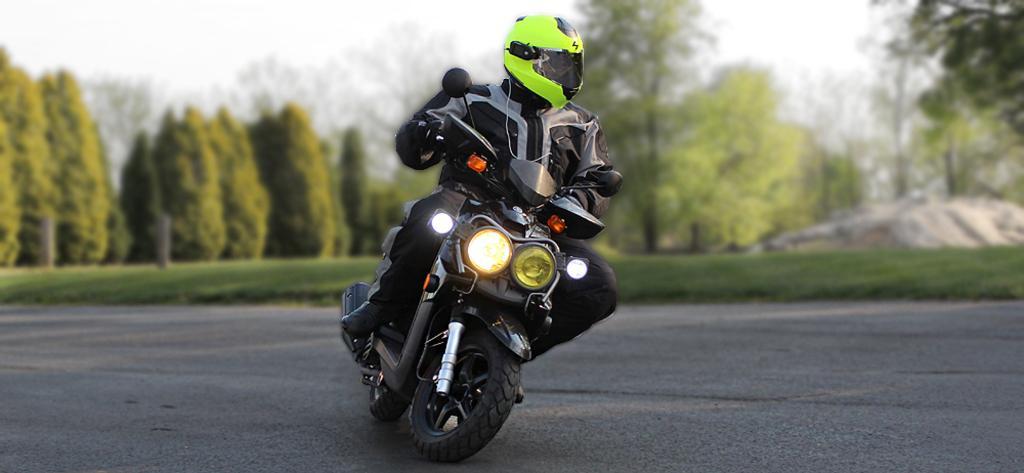Please provide a concise description of this image. In the image there is a person in jacket and helmet riding a bike on the road and behind there are trees on the grassland and above its sky. 